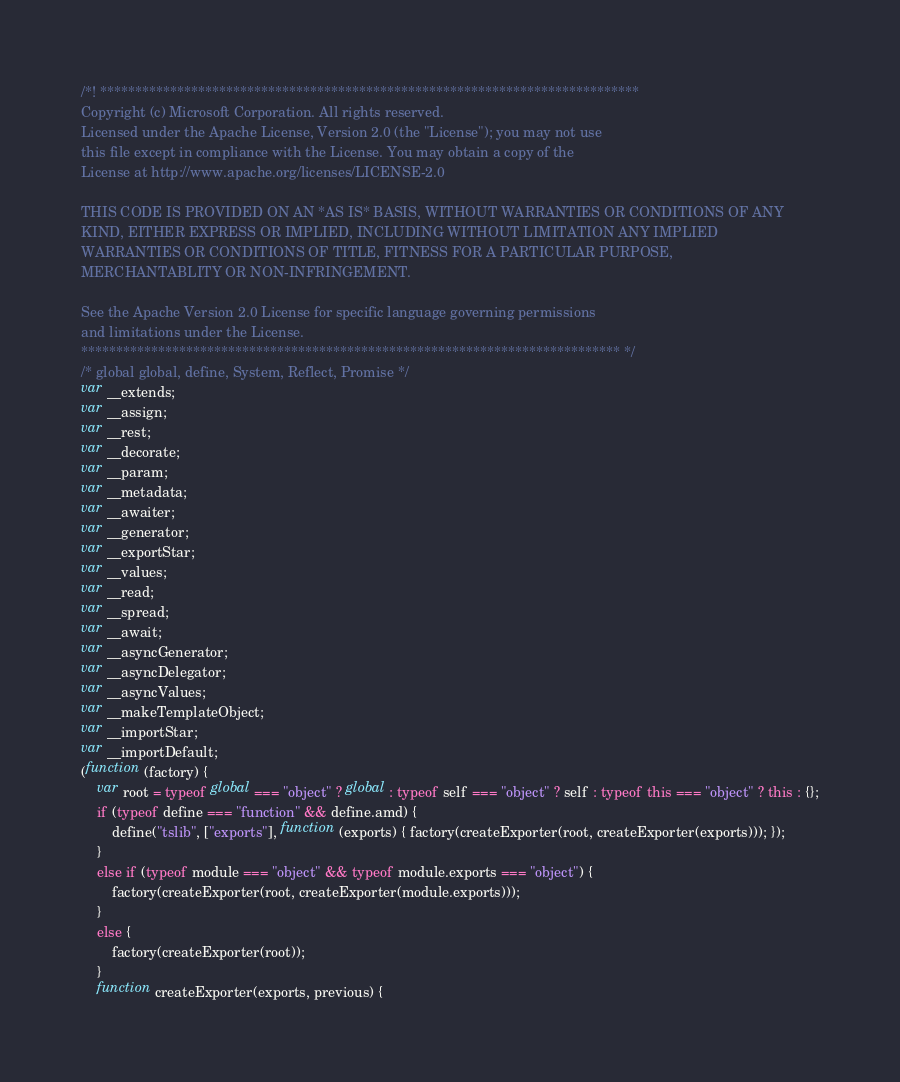<code> <loc_0><loc_0><loc_500><loc_500><_JavaScript_>/*! *****************************************************************************
Copyright (c) Microsoft Corporation. All rights reserved.
Licensed under the Apache License, Version 2.0 (the "License"); you may not use
this file except in compliance with the License. You may obtain a copy of the
License at http://www.apache.org/licenses/LICENSE-2.0

THIS CODE IS PROVIDED ON AN *AS IS* BASIS, WITHOUT WARRANTIES OR CONDITIONS OF ANY
KIND, EITHER EXPRESS OR IMPLIED, INCLUDING WITHOUT LIMITATION ANY IMPLIED
WARRANTIES OR CONDITIONS OF TITLE, FITNESS FOR A PARTICULAR PURPOSE,
MERCHANTABLITY OR NON-INFRINGEMENT.

See the Apache Version 2.0 License for specific language governing permissions
and limitations under the License.
***************************************************************************** */
/* global global, define, System, Reflect, Promise */
var __extends;
var __assign;
var __rest;
var __decorate;
var __param;
var __metadata;
var __awaiter;
var __generator;
var __exportStar;
var __values;
var __read;
var __spread;
var __await;
var __asyncGenerator;
var __asyncDelegator;
var __asyncValues;
var __makeTemplateObject;
var __importStar;
var __importDefault;
(function (factory) {
    var root = typeof global === "object" ? global : typeof self === "object" ? self : typeof this === "object" ? this : {};
    if (typeof define === "function" && define.amd) {
        define("tslib", ["exports"], function (exports) { factory(createExporter(root, createExporter(exports))); });
    }
    else if (typeof module === "object" && typeof module.exports === "object") {
        factory(createExporter(root, createExporter(module.exports)));
    }
    else {
        factory(createExporter(root));
    }
    function createExporter(exports, previous) {</code> 